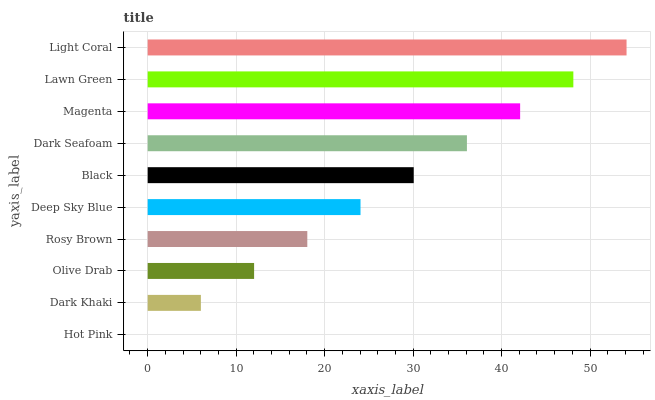Is Hot Pink the minimum?
Answer yes or no. Yes. Is Light Coral the maximum?
Answer yes or no. Yes. Is Dark Khaki the minimum?
Answer yes or no. No. Is Dark Khaki the maximum?
Answer yes or no. No. Is Dark Khaki greater than Hot Pink?
Answer yes or no. Yes. Is Hot Pink less than Dark Khaki?
Answer yes or no. Yes. Is Hot Pink greater than Dark Khaki?
Answer yes or no. No. Is Dark Khaki less than Hot Pink?
Answer yes or no. No. Is Black the high median?
Answer yes or no. Yes. Is Deep Sky Blue the low median?
Answer yes or no. Yes. Is Hot Pink the high median?
Answer yes or no. No. Is Magenta the low median?
Answer yes or no. No. 